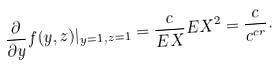<formula> <loc_0><loc_0><loc_500><loc_500>\frac { \partial } { \partial y } f ( y , z ) | _ { y = 1 , z = 1 } = \frac { c } { { E } X } { E } X ^ { 2 } = \frac { c } { c ^ { c r } } .</formula> 